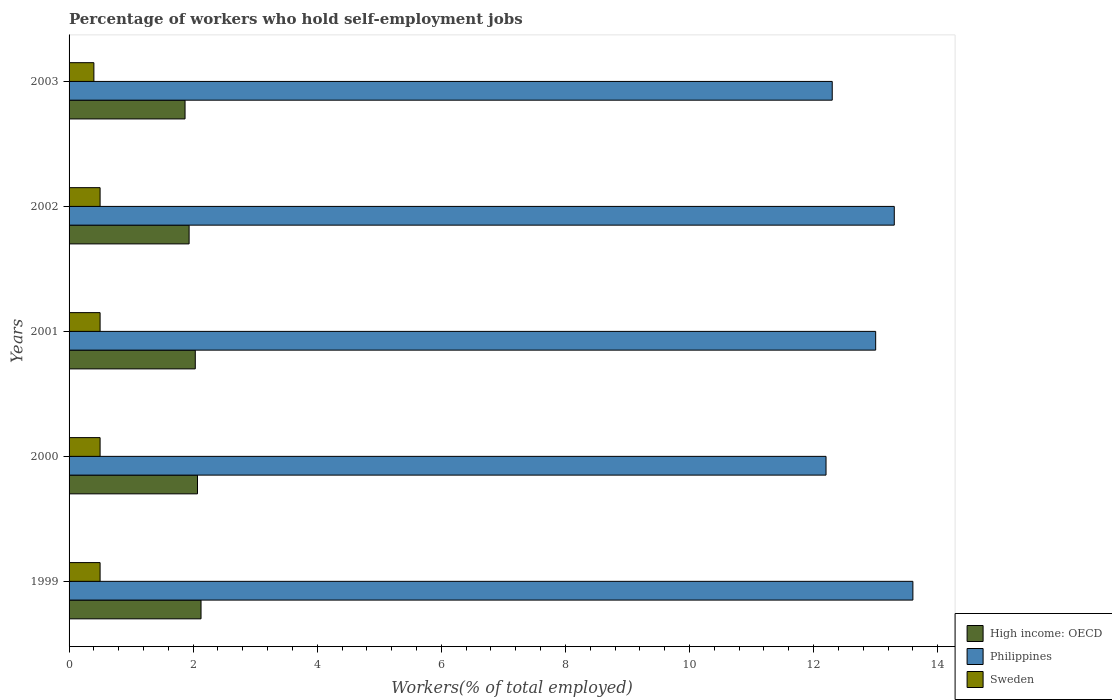How many different coloured bars are there?
Give a very brief answer. 3. Are the number of bars on each tick of the Y-axis equal?
Your answer should be compact. Yes. How many bars are there on the 4th tick from the top?
Make the answer very short. 3. In how many cases, is the number of bars for a given year not equal to the number of legend labels?
Ensure brevity in your answer.  0. What is the percentage of self-employed workers in Philippines in 2003?
Your response must be concise. 12.3. Across all years, what is the maximum percentage of self-employed workers in Philippines?
Provide a short and direct response. 13.6. Across all years, what is the minimum percentage of self-employed workers in High income: OECD?
Make the answer very short. 1.87. In which year was the percentage of self-employed workers in Philippines maximum?
Your response must be concise. 1999. In which year was the percentage of self-employed workers in High income: OECD minimum?
Offer a terse response. 2003. What is the total percentage of self-employed workers in High income: OECD in the graph?
Your response must be concise. 10.03. What is the difference between the percentage of self-employed workers in Philippines in 1999 and that in 2002?
Give a very brief answer. 0.3. What is the difference between the percentage of self-employed workers in Sweden in 2000 and the percentage of self-employed workers in High income: OECD in 2003?
Make the answer very short. -1.37. What is the average percentage of self-employed workers in Sweden per year?
Provide a succinct answer. 0.48. In the year 2000, what is the difference between the percentage of self-employed workers in Sweden and percentage of self-employed workers in High income: OECD?
Offer a very short reply. -1.57. What is the ratio of the percentage of self-employed workers in Philippines in 1999 to that in 2000?
Your answer should be compact. 1.11. Is the difference between the percentage of self-employed workers in Sweden in 1999 and 2002 greater than the difference between the percentage of self-employed workers in High income: OECD in 1999 and 2002?
Ensure brevity in your answer.  No. What is the difference between the highest and the second highest percentage of self-employed workers in Sweden?
Provide a succinct answer. 0. What is the difference between the highest and the lowest percentage of self-employed workers in Sweden?
Provide a succinct answer. 0.1. Is the sum of the percentage of self-employed workers in High income: OECD in 1999 and 2000 greater than the maximum percentage of self-employed workers in Philippines across all years?
Ensure brevity in your answer.  No. What does the 3rd bar from the top in 1999 represents?
Offer a terse response. High income: OECD. What does the 1st bar from the bottom in 1999 represents?
Your answer should be compact. High income: OECD. How many bars are there?
Provide a succinct answer. 15. Does the graph contain any zero values?
Offer a very short reply. No. Does the graph contain grids?
Your answer should be very brief. No. Where does the legend appear in the graph?
Your answer should be very brief. Bottom right. How many legend labels are there?
Offer a terse response. 3. How are the legend labels stacked?
Offer a terse response. Vertical. What is the title of the graph?
Offer a very short reply. Percentage of workers who hold self-employment jobs. Does "Greenland" appear as one of the legend labels in the graph?
Provide a short and direct response. No. What is the label or title of the X-axis?
Provide a short and direct response. Workers(% of total employed). What is the Workers(% of total employed) in High income: OECD in 1999?
Offer a terse response. 2.13. What is the Workers(% of total employed) of Philippines in 1999?
Provide a short and direct response. 13.6. What is the Workers(% of total employed) in High income: OECD in 2000?
Offer a very short reply. 2.07. What is the Workers(% of total employed) in Philippines in 2000?
Your response must be concise. 12.2. What is the Workers(% of total employed) of Sweden in 2000?
Provide a succinct answer. 0.5. What is the Workers(% of total employed) in High income: OECD in 2001?
Ensure brevity in your answer.  2.03. What is the Workers(% of total employed) in Philippines in 2001?
Your response must be concise. 13. What is the Workers(% of total employed) of Sweden in 2001?
Ensure brevity in your answer.  0.5. What is the Workers(% of total employed) of High income: OECD in 2002?
Your answer should be very brief. 1.93. What is the Workers(% of total employed) in Philippines in 2002?
Your answer should be very brief. 13.3. What is the Workers(% of total employed) of High income: OECD in 2003?
Offer a very short reply. 1.87. What is the Workers(% of total employed) in Philippines in 2003?
Give a very brief answer. 12.3. What is the Workers(% of total employed) of Sweden in 2003?
Offer a very short reply. 0.4. Across all years, what is the maximum Workers(% of total employed) of High income: OECD?
Provide a succinct answer. 2.13. Across all years, what is the maximum Workers(% of total employed) of Philippines?
Your response must be concise. 13.6. Across all years, what is the maximum Workers(% of total employed) in Sweden?
Ensure brevity in your answer.  0.5. Across all years, what is the minimum Workers(% of total employed) in High income: OECD?
Your answer should be compact. 1.87. Across all years, what is the minimum Workers(% of total employed) of Philippines?
Your response must be concise. 12.2. Across all years, what is the minimum Workers(% of total employed) of Sweden?
Make the answer very short. 0.4. What is the total Workers(% of total employed) in High income: OECD in the graph?
Your answer should be compact. 10.03. What is the total Workers(% of total employed) of Philippines in the graph?
Keep it short and to the point. 64.4. What is the difference between the Workers(% of total employed) in High income: OECD in 1999 and that in 2000?
Offer a very short reply. 0.06. What is the difference between the Workers(% of total employed) of Philippines in 1999 and that in 2000?
Your response must be concise. 1.4. What is the difference between the Workers(% of total employed) of High income: OECD in 1999 and that in 2001?
Ensure brevity in your answer.  0.09. What is the difference between the Workers(% of total employed) of Philippines in 1999 and that in 2001?
Give a very brief answer. 0.6. What is the difference between the Workers(% of total employed) of High income: OECD in 1999 and that in 2002?
Your answer should be compact. 0.19. What is the difference between the Workers(% of total employed) of Sweden in 1999 and that in 2002?
Your answer should be very brief. 0. What is the difference between the Workers(% of total employed) of High income: OECD in 1999 and that in 2003?
Make the answer very short. 0.26. What is the difference between the Workers(% of total employed) in High income: OECD in 2000 and that in 2001?
Your response must be concise. 0.04. What is the difference between the Workers(% of total employed) in Philippines in 2000 and that in 2001?
Provide a succinct answer. -0.8. What is the difference between the Workers(% of total employed) in High income: OECD in 2000 and that in 2002?
Give a very brief answer. 0.14. What is the difference between the Workers(% of total employed) in High income: OECD in 2000 and that in 2003?
Offer a terse response. 0.2. What is the difference between the Workers(% of total employed) of Philippines in 2000 and that in 2003?
Provide a succinct answer. -0.1. What is the difference between the Workers(% of total employed) in Sweden in 2000 and that in 2003?
Provide a short and direct response. 0.1. What is the difference between the Workers(% of total employed) of High income: OECD in 2001 and that in 2002?
Make the answer very short. 0.1. What is the difference between the Workers(% of total employed) in Philippines in 2001 and that in 2002?
Ensure brevity in your answer.  -0.3. What is the difference between the Workers(% of total employed) in High income: OECD in 2001 and that in 2003?
Ensure brevity in your answer.  0.16. What is the difference between the Workers(% of total employed) in Philippines in 2001 and that in 2003?
Provide a short and direct response. 0.7. What is the difference between the Workers(% of total employed) of Sweden in 2001 and that in 2003?
Your response must be concise. 0.1. What is the difference between the Workers(% of total employed) of High income: OECD in 2002 and that in 2003?
Your answer should be very brief. 0.07. What is the difference between the Workers(% of total employed) of High income: OECD in 1999 and the Workers(% of total employed) of Philippines in 2000?
Offer a very short reply. -10.07. What is the difference between the Workers(% of total employed) in High income: OECD in 1999 and the Workers(% of total employed) in Sweden in 2000?
Ensure brevity in your answer.  1.63. What is the difference between the Workers(% of total employed) in Philippines in 1999 and the Workers(% of total employed) in Sweden in 2000?
Your response must be concise. 13.1. What is the difference between the Workers(% of total employed) of High income: OECD in 1999 and the Workers(% of total employed) of Philippines in 2001?
Your answer should be compact. -10.87. What is the difference between the Workers(% of total employed) of High income: OECD in 1999 and the Workers(% of total employed) of Sweden in 2001?
Offer a very short reply. 1.63. What is the difference between the Workers(% of total employed) of High income: OECD in 1999 and the Workers(% of total employed) of Philippines in 2002?
Ensure brevity in your answer.  -11.17. What is the difference between the Workers(% of total employed) of High income: OECD in 1999 and the Workers(% of total employed) of Sweden in 2002?
Offer a very short reply. 1.63. What is the difference between the Workers(% of total employed) of Philippines in 1999 and the Workers(% of total employed) of Sweden in 2002?
Offer a terse response. 13.1. What is the difference between the Workers(% of total employed) in High income: OECD in 1999 and the Workers(% of total employed) in Philippines in 2003?
Offer a very short reply. -10.17. What is the difference between the Workers(% of total employed) in High income: OECD in 1999 and the Workers(% of total employed) in Sweden in 2003?
Provide a succinct answer. 1.73. What is the difference between the Workers(% of total employed) in Philippines in 1999 and the Workers(% of total employed) in Sweden in 2003?
Give a very brief answer. 13.2. What is the difference between the Workers(% of total employed) of High income: OECD in 2000 and the Workers(% of total employed) of Philippines in 2001?
Offer a terse response. -10.93. What is the difference between the Workers(% of total employed) of High income: OECD in 2000 and the Workers(% of total employed) of Sweden in 2001?
Provide a succinct answer. 1.57. What is the difference between the Workers(% of total employed) in Philippines in 2000 and the Workers(% of total employed) in Sweden in 2001?
Your response must be concise. 11.7. What is the difference between the Workers(% of total employed) of High income: OECD in 2000 and the Workers(% of total employed) of Philippines in 2002?
Ensure brevity in your answer.  -11.23. What is the difference between the Workers(% of total employed) in High income: OECD in 2000 and the Workers(% of total employed) in Sweden in 2002?
Ensure brevity in your answer.  1.57. What is the difference between the Workers(% of total employed) of High income: OECD in 2000 and the Workers(% of total employed) of Philippines in 2003?
Give a very brief answer. -10.23. What is the difference between the Workers(% of total employed) of High income: OECD in 2000 and the Workers(% of total employed) of Sweden in 2003?
Offer a terse response. 1.67. What is the difference between the Workers(% of total employed) in High income: OECD in 2001 and the Workers(% of total employed) in Philippines in 2002?
Ensure brevity in your answer.  -11.27. What is the difference between the Workers(% of total employed) in High income: OECD in 2001 and the Workers(% of total employed) in Sweden in 2002?
Provide a succinct answer. 1.53. What is the difference between the Workers(% of total employed) in High income: OECD in 2001 and the Workers(% of total employed) in Philippines in 2003?
Offer a very short reply. -10.27. What is the difference between the Workers(% of total employed) in High income: OECD in 2001 and the Workers(% of total employed) in Sweden in 2003?
Offer a very short reply. 1.63. What is the difference between the Workers(% of total employed) of Philippines in 2001 and the Workers(% of total employed) of Sweden in 2003?
Offer a terse response. 12.6. What is the difference between the Workers(% of total employed) of High income: OECD in 2002 and the Workers(% of total employed) of Philippines in 2003?
Make the answer very short. -10.37. What is the difference between the Workers(% of total employed) in High income: OECD in 2002 and the Workers(% of total employed) in Sweden in 2003?
Provide a short and direct response. 1.53. What is the average Workers(% of total employed) in High income: OECD per year?
Your answer should be very brief. 2.01. What is the average Workers(% of total employed) in Philippines per year?
Offer a terse response. 12.88. What is the average Workers(% of total employed) of Sweden per year?
Keep it short and to the point. 0.48. In the year 1999, what is the difference between the Workers(% of total employed) in High income: OECD and Workers(% of total employed) in Philippines?
Your response must be concise. -11.47. In the year 1999, what is the difference between the Workers(% of total employed) of High income: OECD and Workers(% of total employed) of Sweden?
Provide a short and direct response. 1.63. In the year 2000, what is the difference between the Workers(% of total employed) in High income: OECD and Workers(% of total employed) in Philippines?
Your answer should be very brief. -10.13. In the year 2000, what is the difference between the Workers(% of total employed) in High income: OECD and Workers(% of total employed) in Sweden?
Give a very brief answer. 1.57. In the year 2000, what is the difference between the Workers(% of total employed) of Philippines and Workers(% of total employed) of Sweden?
Your answer should be compact. 11.7. In the year 2001, what is the difference between the Workers(% of total employed) of High income: OECD and Workers(% of total employed) of Philippines?
Your answer should be very brief. -10.97. In the year 2001, what is the difference between the Workers(% of total employed) of High income: OECD and Workers(% of total employed) of Sweden?
Make the answer very short. 1.53. In the year 2001, what is the difference between the Workers(% of total employed) in Philippines and Workers(% of total employed) in Sweden?
Your answer should be compact. 12.5. In the year 2002, what is the difference between the Workers(% of total employed) of High income: OECD and Workers(% of total employed) of Philippines?
Your response must be concise. -11.37. In the year 2002, what is the difference between the Workers(% of total employed) of High income: OECD and Workers(% of total employed) of Sweden?
Make the answer very short. 1.43. In the year 2002, what is the difference between the Workers(% of total employed) in Philippines and Workers(% of total employed) in Sweden?
Give a very brief answer. 12.8. In the year 2003, what is the difference between the Workers(% of total employed) of High income: OECD and Workers(% of total employed) of Philippines?
Ensure brevity in your answer.  -10.43. In the year 2003, what is the difference between the Workers(% of total employed) of High income: OECD and Workers(% of total employed) of Sweden?
Keep it short and to the point. 1.47. In the year 2003, what is the difference between the Workers(% of total employed) of Philippines and Workers(% of total employed) of Sweden?
Offer a very short reply. 11.9. What is the ratio of the Workers(% of total employed) of High income: OECD in 1999 to that in 2000?
Your answer should be compact. 1.03. What is the ratio of the Workers(% of total employed) of Philippines in 1999 to that in 2000?
Your response must be concise. 1.11. What is the ratio of the Workers(% of total employed) in High income: OECD in 1999 to that in 2001?
Keep it short and to the point. 1.05. What is the ratio of the Workers(% of total employed) in Philippines in 1999 to that in 2001?
Keep it short and to the point. 1.05. What is the ratio of the Workers(% of total employed) in Sweden in 1999 to that in 2001?
Provide a short and direct response. 1. What is the ratio of the Workers(% of total employed) in High income: OECD in 1999 to that in 2002?
Your answer should be compact. 1.1. What is the ratio of the Workers(% of total employed) of Philippines in 1999 to that in 2002?
Make the answer very short. 1.02. What is the ratio of the Workers(% of total employed) in High income: OECD in 1999 to that in 2003?
Ensure brevity in your answer.  1.14. What is the ratio of the Workers(% of total employed) in Philippines in 1999 to that in 2003?
Give a very brief answer. 1.11. What is the ratio of the Workers(% of total employed) of High income: OECD in 2000 to that in 2001?
Offer a very short reply. 1.02. What is the ratio of the Workers(% of total employed) of Philippines in 2000 to that in 2001?
Your response must be concise. 0.94. What is the ratio of the Workers(% of total employed) of High income: OECD in 2000 to that in 2002?
Keep it short and to the point. 1.07. What is the ratio of the Workers(% of total employed) of Philippines in 2000 to that in 2002?
Give a very brief answer. 0.92. What is the ratio of the Workers(% of total employed) of High income: OECD in 2000 to that in 2003?
Offer a terse response. 1.11. What is the ratio of the Workers(% of total employed) of Sweden in 2000 to that in 2003?
Keep it short and to the point. 1.25. What is the ratio of the Workers(% of total employed) in High income: OECD in 2001 to that in 2002?
Provide a short and direct response. 1.05. What is the ratio of the Workers(% of total employed) of Philippines in 2001 to that in 2002?
Your response must be concise. 0.98. What is the ratio of the Workers(% of total employed) in High income: OECD in 2001 to that in 2003?
Provide a short and direct response. 1.09. What is the ratio of the Workers(% of total employed) of Philippines in 2001 to that in 2003?
Your answer should be compact. 1.06. What is the ratio of the Workers(% of total employed) in Sweden in 2001 to that in 2003?
Your answer should be very brief. 1.25. What is the ratio of the Workers(% of total employed) of High income: OECD in 2002 to that in 2003?
Ensure brevity in your answer.  1.03. What is the ratio of the Workers(% of total employed) of Philippines in 2002 to that in 2003?
Make the answer very short. 1.08. What is the difference between the highest and the second highest Workers(% of total employed) in High income: OECD?
Keep it short and to the point. 0.06. What is the difference between the highest and the lowest Workers(% of total employed) in High income: OECD?
Make the answer very short. 0.26. What is the difference between the highest and the lowest Workers(% of total employed) of Sweden?
Offer a terse response. 0.1. 